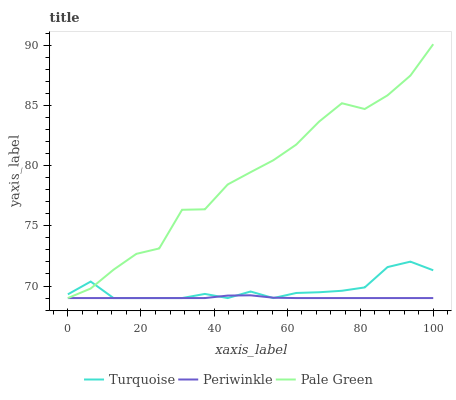Does Periwinkle have the minimum area under the curve?
Answer yes or no. Yes. Does Pale Green have the maximum area under the curve?
Answer yes or no. Yes. Does Pale Green have the minimum area under the curve?
Answer yes or no. No. Does Periwinkle have the maximum area under the curve?
Answer yes or no. No. Is Periwinkle the smoothest?
Answer yes or no. Yes. Is Pale Green the roughest?
Answer yes or no. Yes. Is Pale Green the smoothest?
Answer yes or no. No. Is Periwinkle the roughest?
Answer yes or no. No. Does Turquoise have the lowest value?
Answer yes or no. Yes. Does Pale Green have the highest value?
Answer yes or no. Yes. Does Periwinkle have the highest value?
Answer yes or no. No. Does Periwinkle intersect Pale Green?
Answer yes or no. Yes. Is Periwinkle less than Pale Green?
Answer yes or no. No. Is Periwinkle greater than Pale Green?
Answer yes or no. No. 